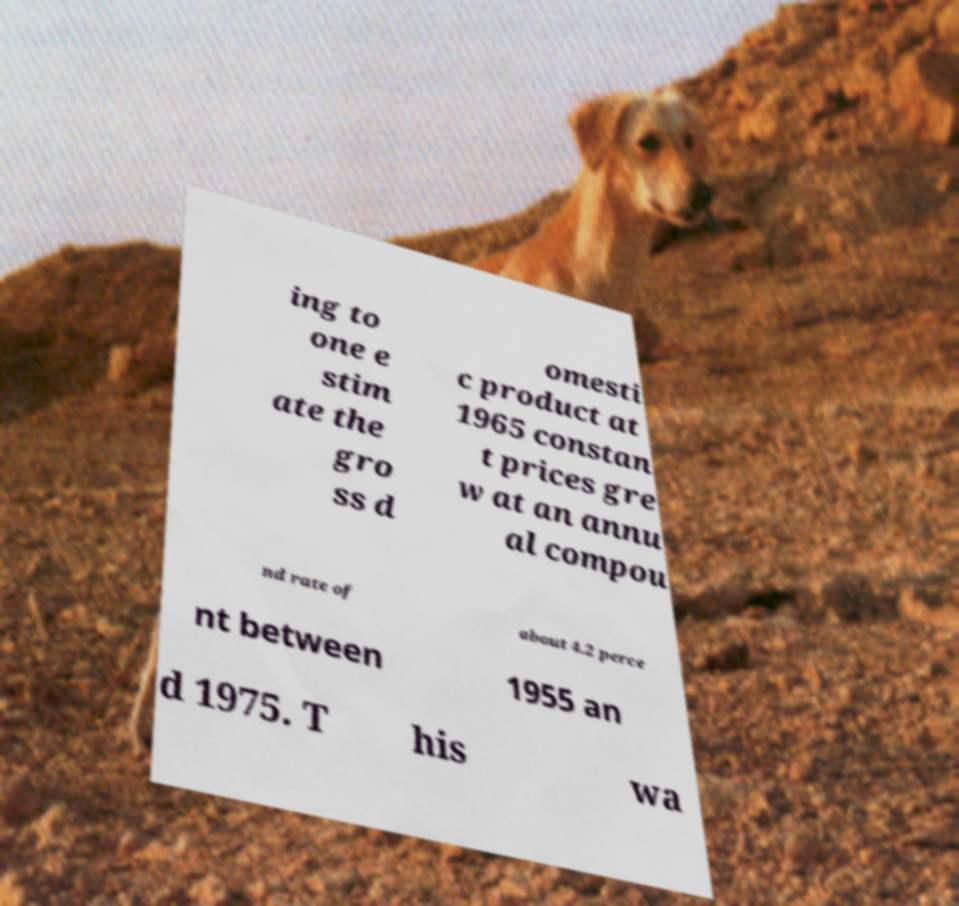Can you read and provide the text displayed in the image?This photo seems to have some interesting text. Can you extract and type it out for me? ing to one e stim ate the gro ss d omesti c product at 1965 constan t prices gre w at an annu al compou nd rate of about 4.2 perce nt between 1955 an d 1975. T his wa 